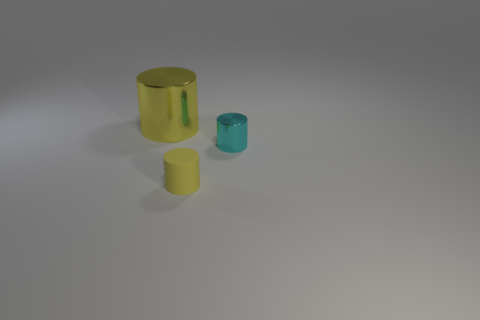Subtract all small cylinders. How many cylinders are left? 1 Add 1 small yellow cylinders. How many objects exist? 4 Subtract all cyan cylinders. How many cylinders are left? 2 Subtract all cyan cylinders. Subtract all yellow cubes. How many cylinders are left? 2 Subtract all red cubes. How many yellow cylinders are left? 2 Subtract all small yellow matte cylinders. Subtract all big yellow shiny cylinders. How many objects are left? 1 Add 1 big yellow objects. How many big yellow objects are left? 2 Add 2 tiny yellow rubber cylinders. How many tiny yellow rubber cylinders exist? 3 Subtract 0 purple balls. How many objects are left? 3 Subtract 3 cylinders. How many cylinders are left? 0 